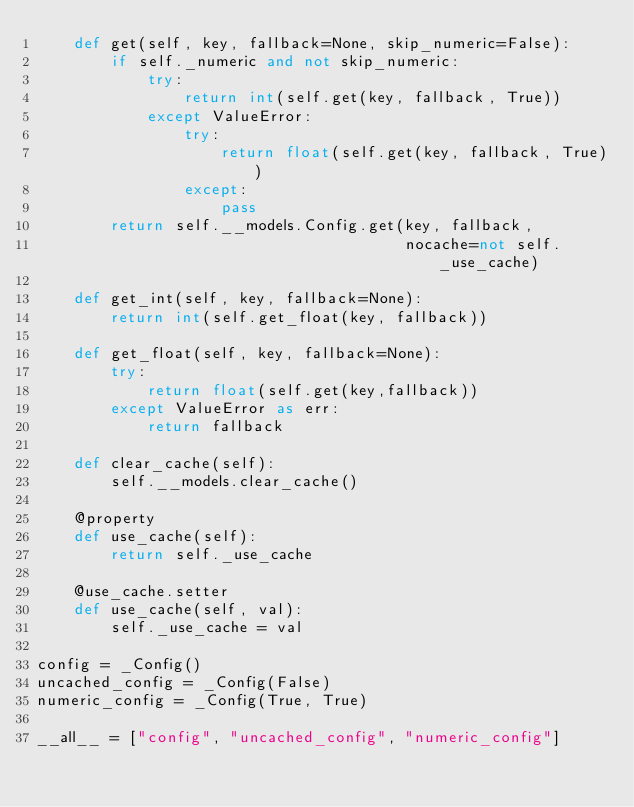<code> <loc_0><loc_0><loc_500><loc_500><_Python_>    def get(self, key, fallback=None, skip_numeric=False):
        if self._numeric and not skip_numeric:
            try:
                return int(self.get(key, fallback, True))
            except ValueError:
                try:
                    return float(self.get(key, fallback, True))
                except:
                    pass
        return self.__models.Config.get(key, fallback,
                                        nocache=not self._use_cache)

    def get_int(self, key, fallback=None):
        return int(self.get_float(key, fallback))
    
    def get_float(self, key, fallback=None):
        try:
            return float(self.get(key,fallback))
        except ValueError as err:
            return fallback

    def clear_cache(self):
        self.__models.clear_cache()

    @property
    def use_cache(self):
        return self._use_cache

    @use_cache.setter
    def use_cache(self, val):
        self._use_cache = val

config = _Config()
uncached_config = _Config(False)
numeric_config = _Config(True, True)

__all__ = ["config", "uncached_config", "numeric_config"]
</code> 